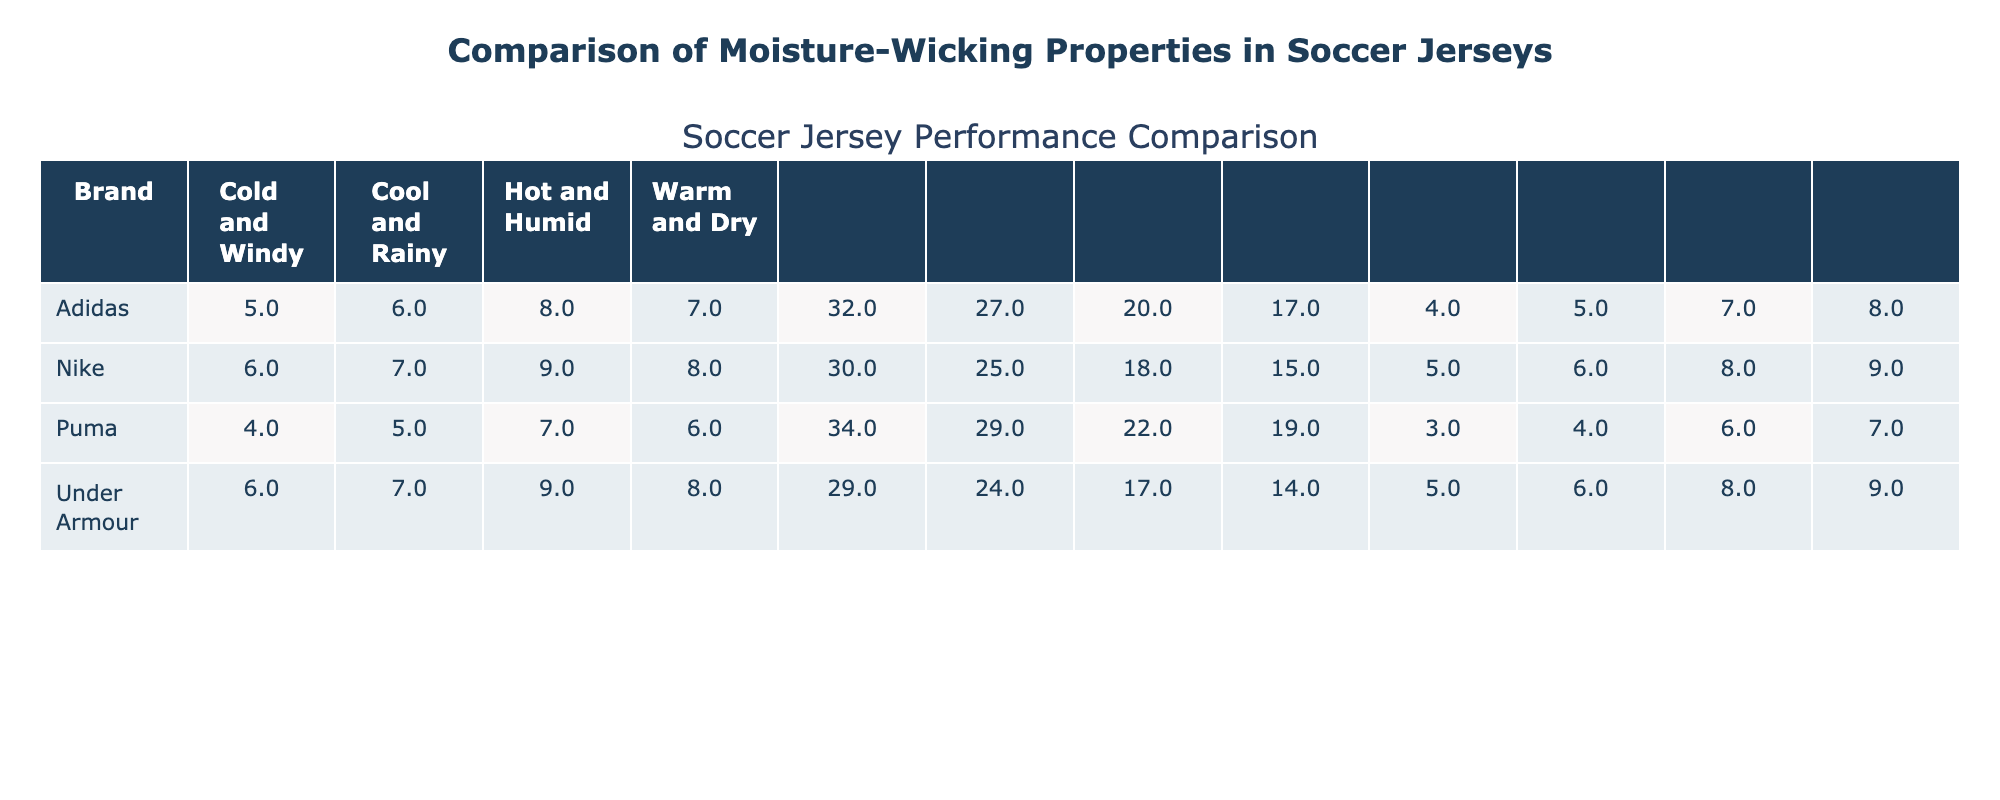What is the moisture-wicking rating of the Nike jersey in hot and humid conditions? According to the table, the moisture-wicking rating for Nike in hot and humid conditions is specifically listed.
Answer: 9 What is the average drying time for Adidas jerseys across all weather conditions? To find the average drying time for Adidas, sum the drying times: 20 + 17 + 27 + 32 = 96, and divide by the number of conditions (4): 96 / 4 = 24.
Answer: 24 minutes Which brand has the highest moisture-wicking rating in warm and dry conditions? The table lists the moisture-wicking ratings for each brand in warm and dry conditions, showing that Nike has the highest rating of 8.
Answer: Nike True or False: The Puma jersey has a higher player comfort score in cool and rainy conditions than in cold and windy conditions. Checking the player comfort scores for Puma: cool and rainy is 4, and cold and windy is 3. Since 4 is greater than 3, the statement is true.
Answer: True What is the difference in moisture-wicking ratings between the Under Armour and Puma jerseys in hot and humid conditions? The moisture-wicking rating for Under Armour in hot and humid is 9, and for Puma, it is 7. The difference is 9 - 7 = 2.
Answer: 2 How does the average player comfort score for Nike compare to that for Puma in cool and rainy conditions? Nike's player comfort score in cool and rainy is 6, while Puma's is 4. The average for Nike is higher than Puma's.
Answer: Nike has a higher average score Which brand consistently performs the best in terms of player comfort score across all weather conditions? By examining the player comfort scores for each brand in all conditions, it's determined that Under Armour has the highest scores overall.
Answer: Under Armour What is the player comfort score for Adidas jerseys in warm and dry conditions? The table directly provides the player comfort score for Adidas in warm and dry conditions, which is 8.
Answer: 8 How many more minutes does it take for the Puma jersey to dry in cold and windy conditions compared to the Under Armour jersey? The drying time for Puma in cold and windy is 34 minutes, and for Under Armour, it is 29 minutes. The difference is 34 - 29 = 5 minutes.
Answer: 5 minutes Is there any weather condition where Nike has a moisture-wicking rating below 7? A review of the table shows that Nike's moisture-wicking ratings in all conditions are 9, 8, and 7, so it never drops below 7.
Answer: No 